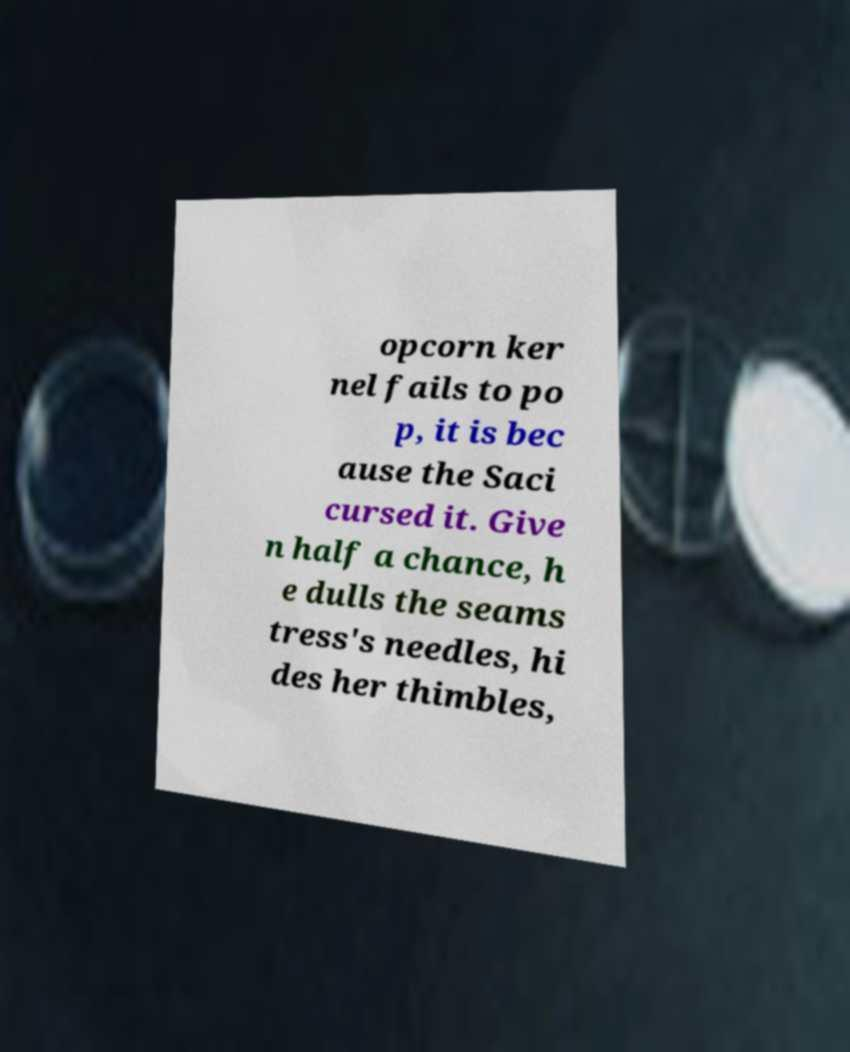I need the written content from this picture converted into text. Can you do that? opcorn ker nel fails to po p, it is bec ause the Saci cursed it. Give n half a chance, h e dulls the seams tress's needles, hi des her thimbles, 